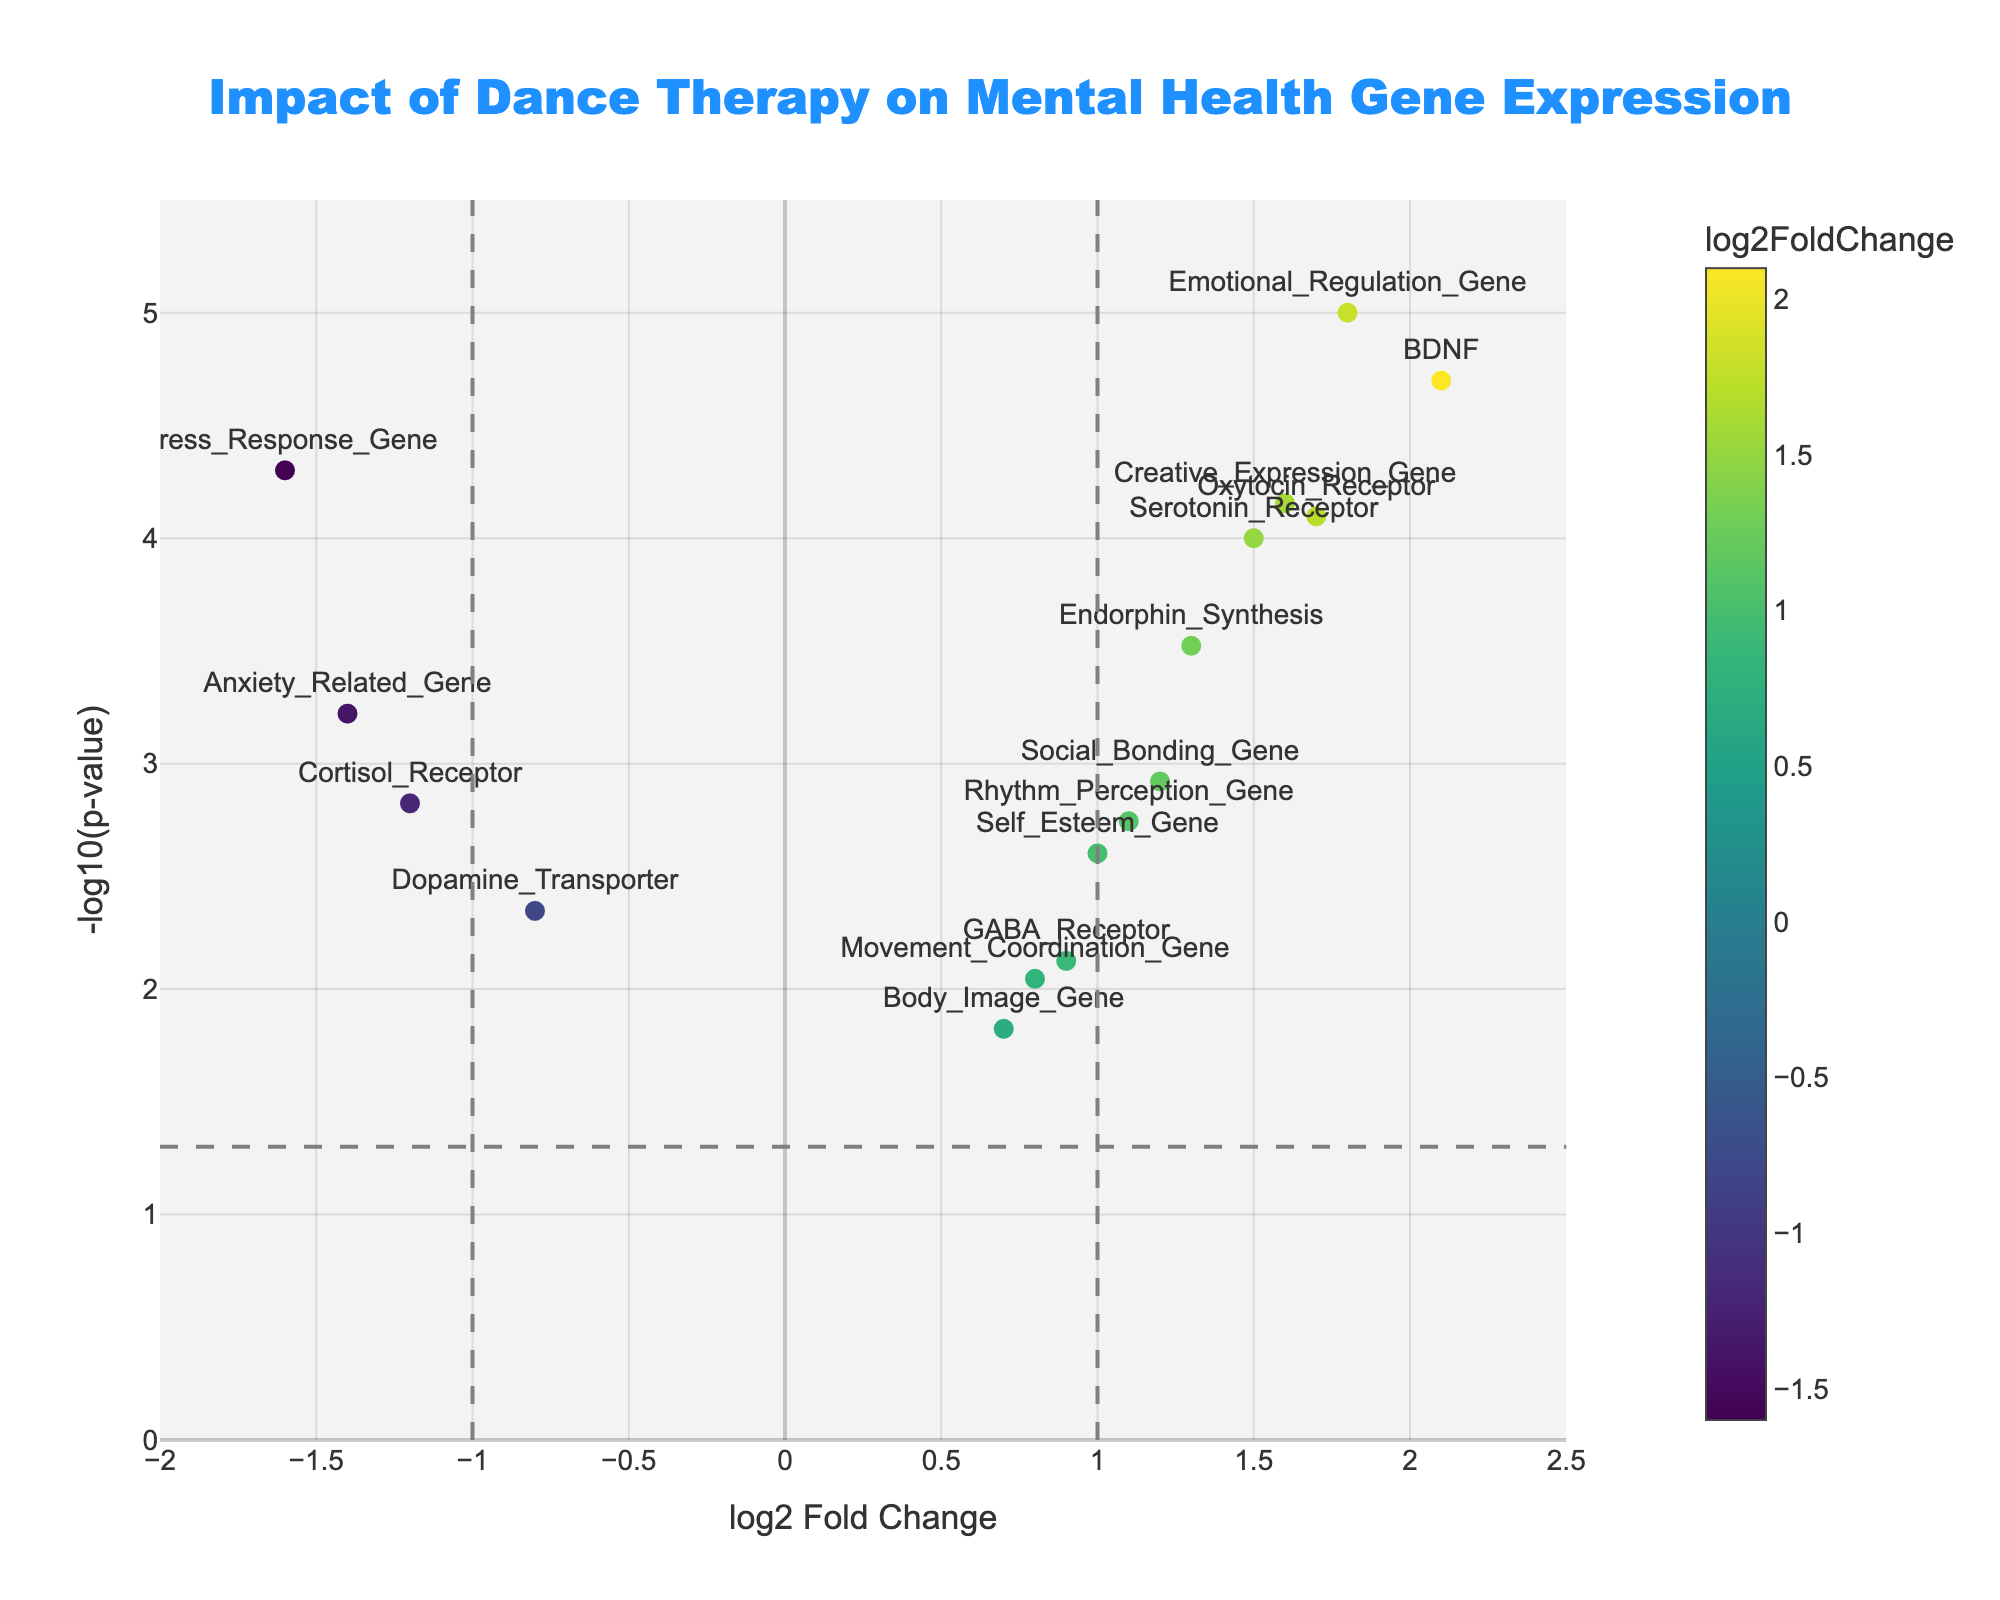How many genes have a p-value less than 0.05? Count the points that are above the horizontal line at y = -log10(0.05)
Answer: 16 What is the name of the gene with the highest log2 fold change? Identify the point furthest to the right on the x-axis and display its label
Answer: BDNF Which genes have a higher log2 fold change than the Serotonin Receptor? Compare log2 fold changes of all genes with Serotonin Receptor (1.5), and find those with higher values
Answer: BDNF, Oxytocin_Receptor, Emotional_Regulation_Gene, Creative_Expression_Gene Which genes are significantly downregulated (log2 fold change less than -1 and p-value < 0.05)? Identify points to the left of -1 on the x-axis and above the horizontal line y = -log10(0.05)
Answer: Cortisol_Receptor, Stress_Response_Gene, Anxiety_Related_Gene What is the range of the log2 fold change in the plot? Determine the minimum and maximum values of log2 fold change on the horizontal axis
Answer: -1.6 to 2.1 Which gene is positioned closest to the vertical dashed line at log2 fold change = 1? Find the point nearest to x = 1
Answer: Social_Bonding_Gene What is the log2 fold change and p-value of the Emotional Regulation Gene? Read the values directly from the point labeled "Emotional_Regulation_Gene"
Answer: log2FC: 1.8, p-value: 0.00001 Are there more upregulated or downregulated genes with a significant p-value (< 0.05)? Count the number of points with log2 fold change > 0 and < 0, and p-value < 0.05
Answer: More upregulated Which genes have a log2 fold change between -1 and 1 and are not significantly different (p-value > 0.05)? Identify points between -1 and 1 on the x-axis and below the horizontal line y = -log10(0.05)
Answer: None 